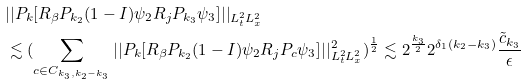<formula> <loc_0><loc_0><loc_500><loc_500>& | | P _ { k } [ R _ { \beta } P _ { k _ { 2 } } ( 1 - I ) \psi _ { 2 } R _ { j } P _ { k _ { 3 } } \psi _ { 3 } ] | | _ { L _ { t } ^ { 2 } L _ { x } ^ { 2 } } \\ & \lesssim ( \sum _ { c \in C _ { k _ { 3 } , k _ { 2 } - k _ { 3 } } } | | P _ { k } [ R _ { \beta } P _ { k _ { 2 } } ( 1 - I ) \psi _ { 2 } R _ { j } P _ { c } \psi _ { 3 } ] | | _ { L _ { t } ^ { 2 } L _ { x } ^ { 2 } } ^ { 2 } ) ^ { \frac { 1 } { 2 } } \lesssim 2 ^ { \frac { k _ { 3 } } { 2 } } 2 ^ { \delta _ { 1 } ( k _ { 2 } - k _ { 3 } ) } \frac { \tilde { c } _ { k _ { 3 } } } { \epsilon } \\</formula> 